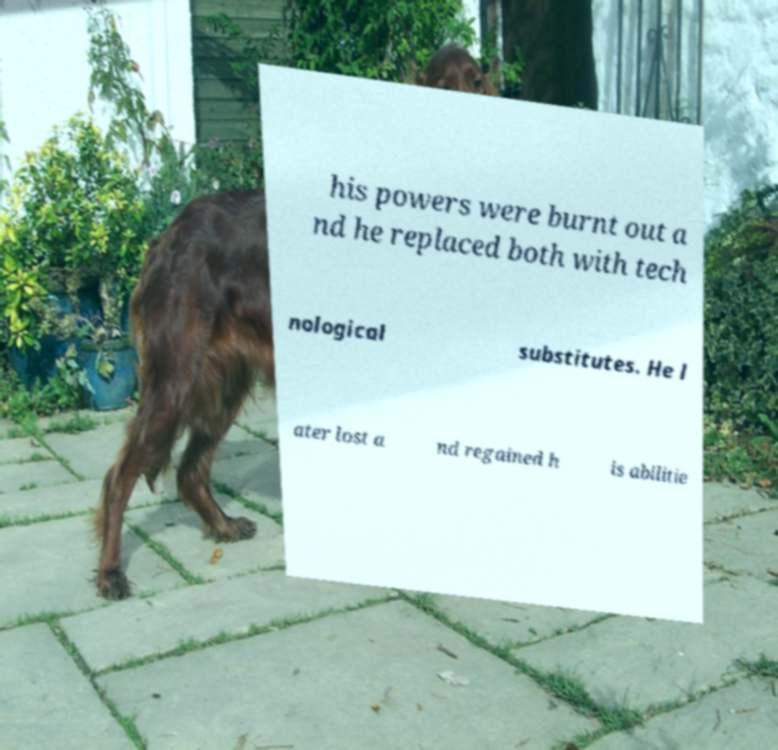Can you accurately transcribe the text from the provided image for me? his powers were burnt out a nd he replaced both with tech nological substitutes. He l ater lost a nd regained h is abilitie 